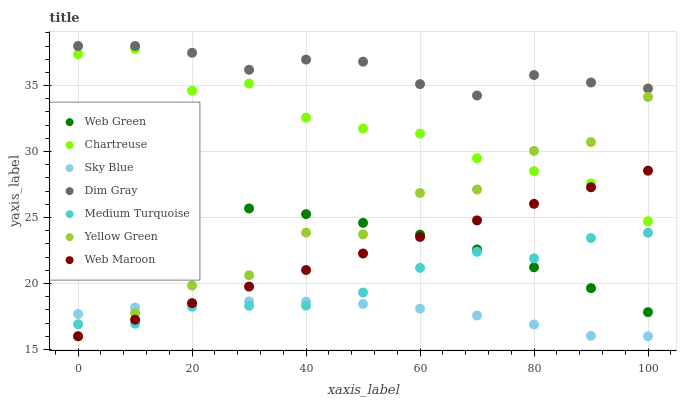Does Sky Blue have the minimum area under the curve?
Answer yes or no. Yes. Does Dim Gray have the maximum area under the curve?
Answer yes or no. Yes. Does Yellow Green have the minimum area under the curve?
Answer yes or no. No. Does Yellow Green have the maximum area under the curve?
Answer yes or no. No. Is Web Maroon the smoothest?
Answer yes or no. Yes. Is Yellow Green the roughest?
Answer yes or no. Yes. Is Yellow Green the smoothest?
Answer yes or no. No. Is Web Maroon the roughest?
Answer yes or no. No. Does Yellow Green have the lowest value?
Answer yes or no. Yes. Does Web Green have the lowest value?
Answer yes or no. No. Does Dim Gray have the highest value?
Answer yes or no. Yes. Does Yellow Green have the highest value?
Answer yes or no. No. Is Web Maroon less than Dim Gray?
Answer yes or no. Yes. Is Dim Gray greater than Chartreuse?
Answer yes or no. Yes. Does Yellow Green intersect Sky Blue?
Answer yes or no. Yes. Is Yellow Green less than Sky Blue?
Answer yes or no. No. Is Yellow Green greater than Sky Blue?
Answer yes or no. No. Does Web Maroon intersect Dim Gray?
Answer yes or no. No. 